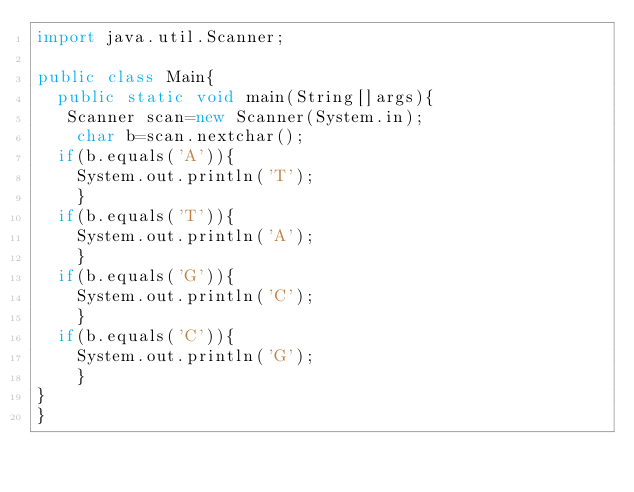Convert code to text. <code><loc_0><loc_0><loc_500><loc_500><_Java_>import java.util.Scanner;

public class Main{
  public static void main(String[]args){
   Scanner scan=new Scanner(System.in);
    char b=scan.nextchar();
  if(b.equals('A')){
    System.out.println('T');
    }
  if(b.equals('T')){
    System.out.println('A');
    }
  if(b.equals('G')){
    System.out.println('C');
    }
  if(b.equals('C')){
    System.out.println('G');
    }
}
}
  </code> 